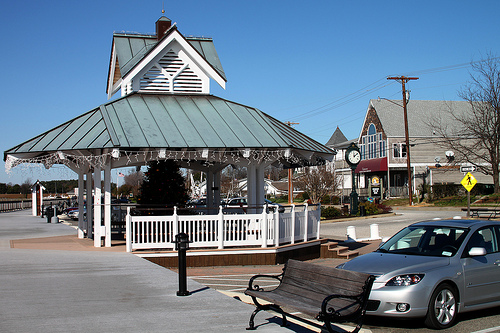Please provide a short description for this region: [0.88, 0.77, 0.9, 0.8]. The region defined by coordinates [0.88, 0.77, 0.9, 0.8] depicts the front wheel of a car. 